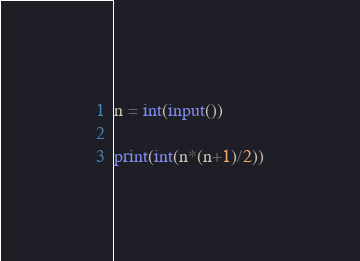Convert code to text. <code><loc_0><loc_0><loc_500><loc_500><_Python_>n = int(input())
 
print(int(n*(n+1)/2))</code> 